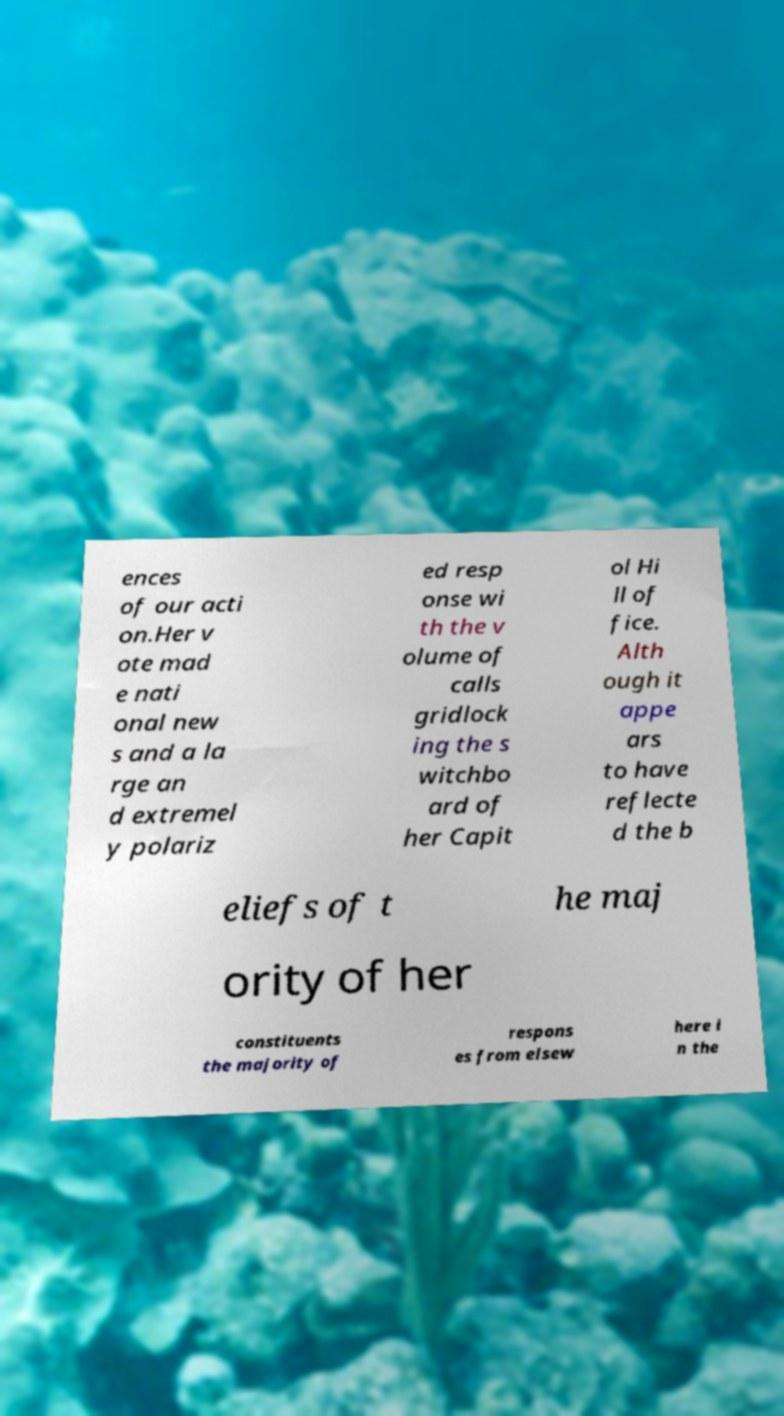What messages or text are displayed in this image? I need them in a readable, typed format. ences of our acti on.Her v ote mad e nati onal new s and a la rge an d extremel y polariz ed resp onse wi th the v olume of calls gridlock ing the s witchbo ard of her Capit ol Hi ll of fice. Alth ough it appe ars to have reflecte d the b eliefs of t he maj ority of her constituents the majority of respons es from elsew here i n the 